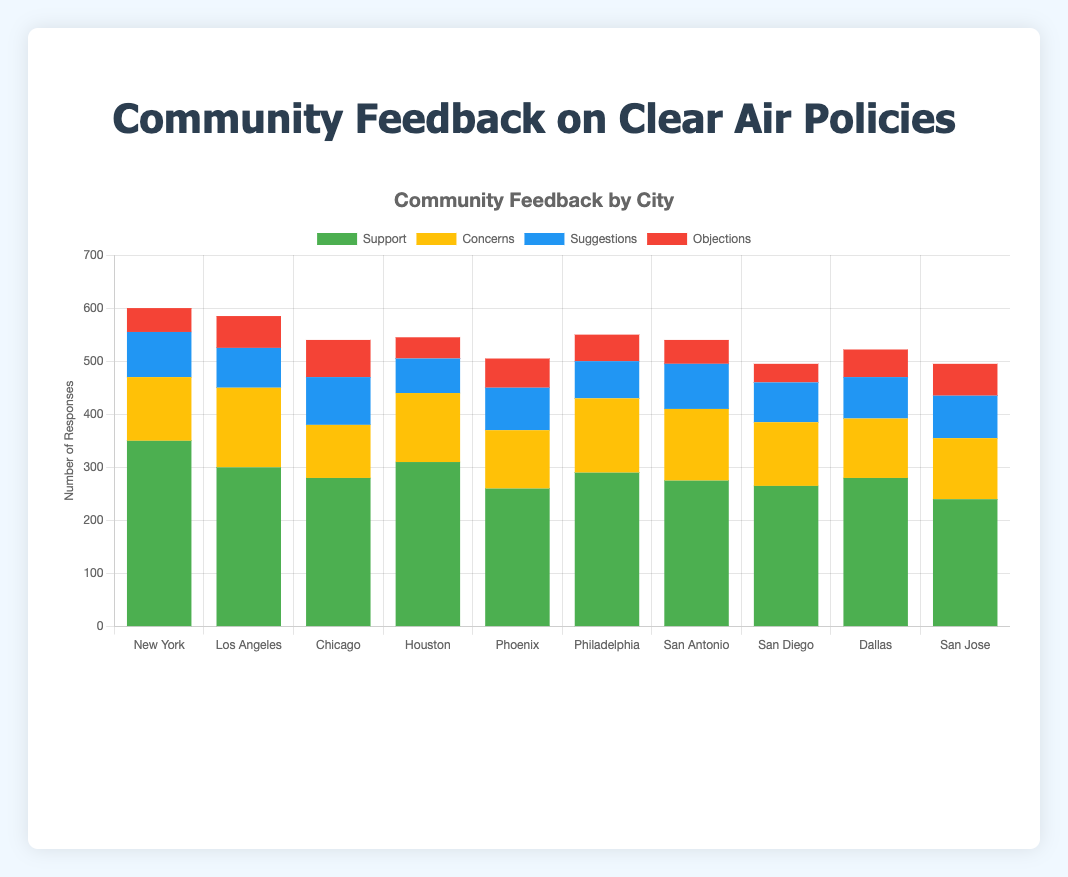What's the total number of supports across all cities? Sum the 'Support' values for each city: 350 + 300 + 280 + 310 + 260 + 290 + 275 + 265 + 280 + 240 = 2850
Answer: 2850 Which city has the highest number of objections? Compare the 'Objections' values for all cities: New York (45), Los Angeles (60), Chicago (70), Houston (40), Phoenix (55), Philadelphia (50), San Antonio (45), San Diego (35), Dallas (52), San Jose (60). Chicago has the highest with 70.
Answer: Chicago What is the combined total of suggestions and objections for San Diego? Add the 'Suggestions' and 'Objections' values for San Diego: 75 + 35 = 110
Answer: 110 Which city has the lowest number of concerns? Compare the 'Concerns' values for all cities: New York (120), Los Angeles (150), Chicago (100), Houston (130), Phoenix (110), Philadelphia (140), San Antonio (135), San Diego (120), Dallas (112), San Jose (115). Chicago has the lowest with 100.
Answer: Chicago How many more suggestions does Chicago have compared to Houston? Subtract Houston's 'Suggestions' from Chicago's 'Suggestions': 90 - 65 = 25
Answer: 25 What is the average number of supports for the top three cities with the highest support rates? Identify the top three cities with the highest supports: New York (350), Houston (310), Los Angeles (300). Calculate the average: (350 + 310 + 300) / 3 = 320
Answer: 320 Which city has the second-highest combined total of concerns and objections? First, calculate the combined total for concerns and objections for each city: 
- New York: 120 + 45 = 165
- Los Angeles: 150 + 60 = 210
- Chicago: 100 + 70 = 170
- Houston: 130 + 40 = 170
- Phoenix: 110 + 55 = 165
- Philadelphia: 140 + 50 = 190
- San Antonio: 135 + 45 = 180
- San Diego: 120 + 35 = 155
- Dallas: 112 + 52 = 164
- San Jose: 115 + 60 = 175
Los Angeles has the highest (210), followed by San Jose (175).
Answer: San Jose 